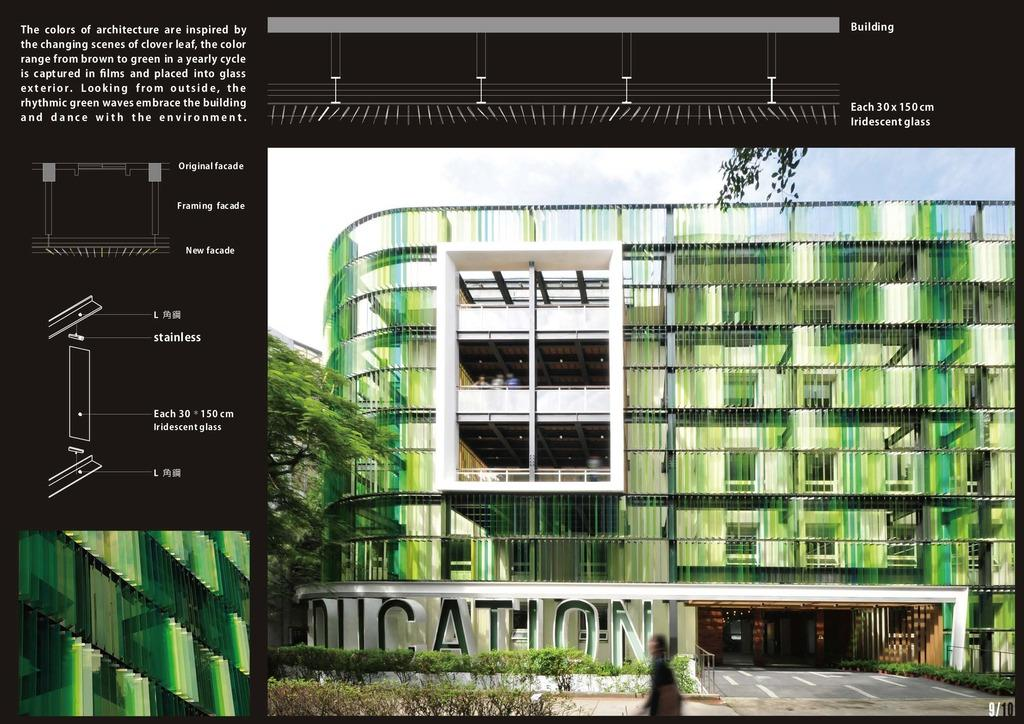What type of vegetation can be seen in the image? There are plants and trees in the image. What type of ground surface is visible in the image? There is grass in the image. What type of structure is present in the image? There is a building in the image. Is there a person present in the image? Yes, there is a person in the image. What part of the natural environment is visible in the image? The sky is visible in the image. What type of oil can be seen dripping from the trees in the image? There is no oil present in the image; it features plants, trees, grass, a building, a person, and the sky. How many matches are visible in the image? There are no matches present in the image. 